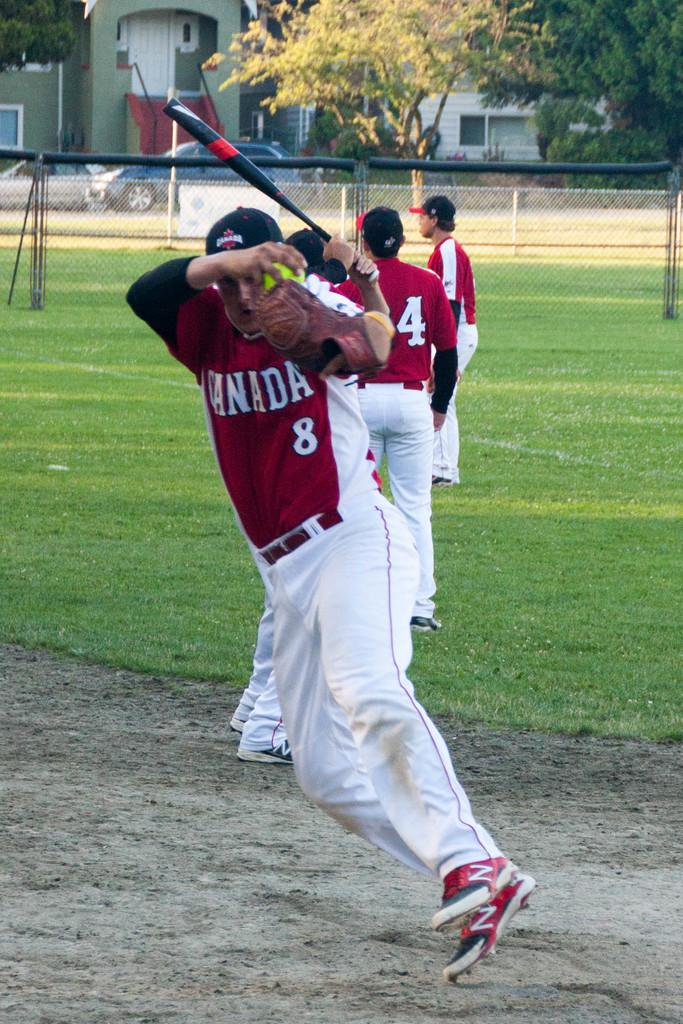<image>
Present a compact description of the photo's key features. A baseball player for the Canada team is about to fall down. 